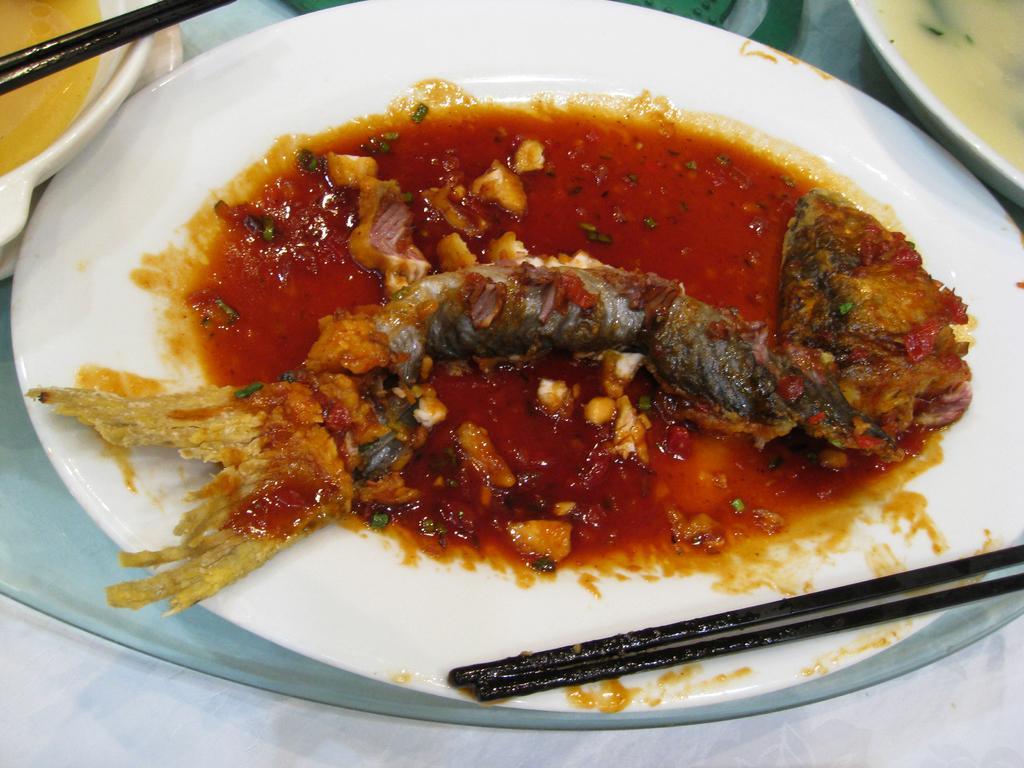Please provide a concise description of this image. In this image there is a plate in which there is a fish curry in it. There are chopsticks beside the plate. 